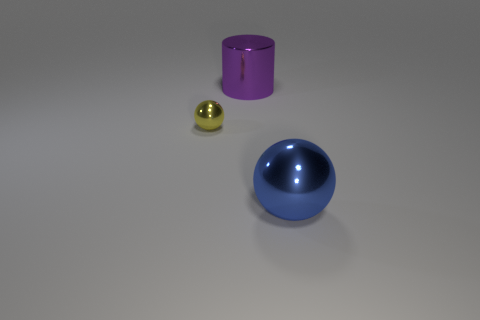Add 1 cylinders. How many objects exist? 4 Subtract all balls. How many objects are left? 1 Subtract all blue spheres. Subtract all cyan cubes. How many spheres are left? 1 Subtract all cylinders. Subtract all blue metallic things. How many objects are left? 1 Add 1 blue metal things. How many blue metal things are left? 2 Add 2 blue metallic balls. How many blue metallic balls exist? 3 Subtract 0 green blocks. How many objects are left? 3 